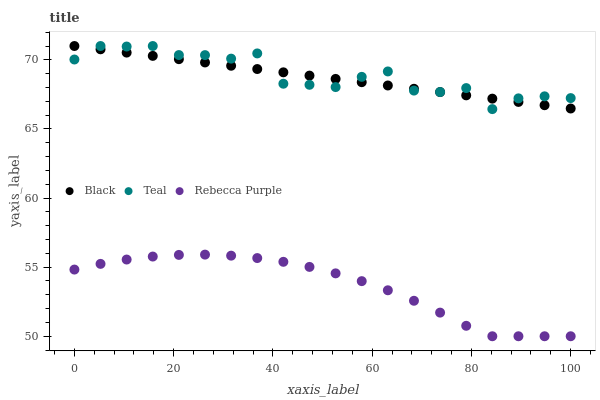Does Rebecca Purple have the minimum area under the curve?
Answer yes or no. Yes. Does Teal have the maximum area under the curve?
Answer yes or no. Yes. Does Teal have the minimum area under the curve?
Answer yes or no. No. Does Rebecca Purple have the maximum area under the curve?
Answer yes or no. No. Is Black the smoothest?
Answer yes or no. Yes. Is Teal the roughest?
Answer yes or no. Yes. Is Rebecca Purple the smoothest?
Answer yes or no. No. Is Rebecca Purple the roughest?
Answer yes or no. No. Does Rebecca Purple have the lowest value?
Answer yes or no. Yes. Does Teal have the lowest value?
Answer yes or no. No. Does Teal have the highest value?
Answer yes or no. Yes. Does Rebecca Purple have the highest value?
Answer yes or no. No. Is Rebecca Purple less than Teal?
Answer yes or no. Yes. Is Teal greater than Rebecca Purple?
Answer yes or no. Yes. Does Black intersect Teal?
Answer yes or no. Yes. Is Black less than Teal?
Answer yes or no. No. Is Black greater than Teal?
Answer yes or no. No. Does Rebecca Purple intersect Teal?
Answer yes or no. No. 